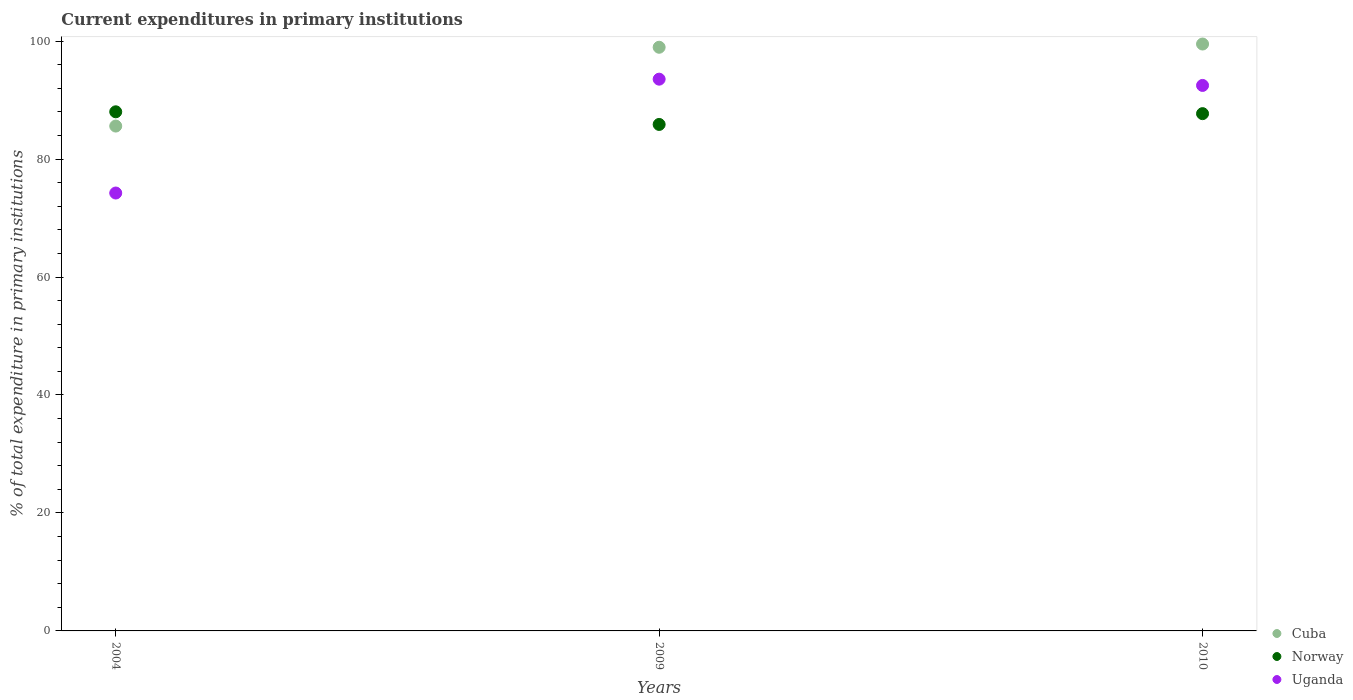Is the number of dotlines equal to the number of legend labels?
Your answer should be very brief. Yes. What is the current expenditures in primary institutions in Norway in 2010?
Ensure brevity in your answer.  87.7. Across all years, what is the maximum current expenditures in primary institutions in Cuba?
Offer a very short reply. 99.5. Across all years, what is the minimum current expenditures in primary institutions in Cuba?
Provide a short and direct response. 85.59. In which year was the current expenditures in primary institutions in Cuba maximum?
Make the answer very short. 2010. In which year was the current expenditures in primary institutions in Norway minimum?
Ensure brevity in your answer.  2009. What is the total current expenditures in primary institutions in Cuba in the graph?
Your answer should be very brief. 284.05. What is the difference between the current expenditures in primary institutions in Norway in 2009 and that in 2010?
Keep it short and to the point. -1.83. What is the difference between the current expenditures in primary institutions in Cuba in 2004 and the current expenditures in primary institutions in Uganda in 2009?
Ensure brevity in your answer.  -7.95. What is the average current expenditures in primary institutions in Cuba per year?
Keep it short and to the point. 94.68. In the year 2009, what is the difference between the current expenditures in primary institutions in Norway and current expenditures in primary institutions in Cuba?
Provide a succinct answer. -13.09. In how many years, is the current expenditures in primary institutions in Norway greater than 48 %?
Give a very brief answer. 3. What is the ratio of the current expenditures in primary institutions in Cuba in 2009 to that in 2010?
Your response must be concise. 0.99. Is the current expenditures in primary institutions in Norway in 2009 less than that in 2010?
Give a very brief answer. Yes. Is the difference between the current expenditures in primary institutions in Norway in 2004 and 2010 greater than the difference between the current expenditures in primary institutions in Cuba in 2004 and 2010?
Your answer should be compact. Yes. What is the difference between the highest and the second highest current expenditures in primary institutions in Norway?
Your answer should be compact. 0.31. What is the difference between the highest and the lowest current expenditures in primary institutions in Uganda?
Offer a terse response. 19.3. In how many years, is the current expenditures in primary institutions in Norway greater than the average current expenditures in primary institutions in Norway taken over all years?
Make the answer very short. 2. Is the sum of the current expenditures in primary institutions in Cuba in 2004 and 2010 greater than the maximum current expenditures in primary institutions in Uganda across all years?
Provide a succinct answer. Yes. Is it the case that in every year, the sum of the current expenditures in primary institutions in Uganda and current expenditures in primary institutions in Norway  is greater than the current expenditures in primary institutions in Cuba?
Offer a terse response. Yes. Is the current expenditures in primary institutions in Cuba strictly less than the current expenditures in primary institutions in Norway over the years?
Your answer should be very brief. No. How many dotlines are there?
Provide a short and direct response. 3. Are the values on the major ticks of Y-axis written in scientific E-notation?
Ensure brevity in your answer.  No. Does the graph contain any zero values?
Make the answer very short. No. Where does the legend appear in the graph?
Offer a very short reply. Bottom right. How many legend labels are there?
Provide a short and direct response. 3. How are the legend labels stacked?
Give a very brief answer. Vertical. What is the title of the graph?
Give a very brief answer. Current expenditures in primary institutions. Does "Iraq" appear as one of the legend labels in the graph?
Keep it short and to the point. No. What is the label or title of the X-axis?
Give a very brief answer. Years. What is the label or title of the Y-axis?
Offer a terse response. % of total expenditure in primary institutions. What is the % of total expenditure in primary institutions in Cuba in 2004?
Offer a very short reply. 85.59. What is the % of total expenditure in primary institutions of Norway in 2004?
Make the answer very short. 88.01. What is the % of total expenditure in primary institutions of Uganda in 2004?
Your response must be concise. 74.24. What is the % of total expenditure in primary institutions in Cuba in 2009?
Offer a terse response. 98.96. What is the % of total expenditure in primary institutions in Norway in 2009?
Your answer should be compact. 85.87. What is the % of total expenditure in primary institutions in Uganda in 2009?
Provide a short and direct response. 93.55. What is the % of total expenditure in primary institutions in Cuba in 2010?
Keep it short and to the point. 99.5. What is the % of total expenditure in primary institutions of Norway in 2010?
Give a very brief answer. 87.7. What is the % of total expenditure in primary institutions in Uganda in 2010?
Provide a short and direct response. 92.48. Across all years, what is the maximum % of total expenditure in primary institutions in Cuba?
Your answer should be compact. 99.5. Across all years, what is the maximum % of total expenditure in primary institutions in Norway?
Keep it short and to the point. 88.01. Across all years, what is the maximum % of total expenditure in primary institutions of Uganda?
Your answer should be very brief. 93.55. Across all years, what is the minimum % of total expenditure in primary institutions of Cuba?
Offer a terse response. 85.59. Across all years, what is the minimum % of total expenditure in primary institutions of Norway?
Ensure brevity in your answer.  85.87. Across all years, what is the minimum % of total expenditure in primary institutions of Uganda?
Your answer should be compact. 74.24. What is the total % of total expenditure in primary institutions of Cuba in the graph?
Make the answer very short. 284.05. What is the total % of total expenditure in primary institutions of Norway in the graph?
Your answer should be very brief. 261.58. What is the total % of total expenditure in primary institutions in Uganda in the graph?
Offer a terse response. 260.27. What is the difference between the % of total expenditure in primary institutions of Cuba in 2004 and that in 2009?
Give a very brief answer. -13.36. What is the difference between the % of total expenditure in primary institutions in Norway in 2004 and that in 2009?
Offer a very short reply. 2.14. What is the difference between the % of total expenditure in primary institutions of Uganda in 2004 and that in 2009?
Give a very brief answer. -19.3. What is the difference between the % of total expenditure in primary institutions in Cuba in 2004 and that in 2010?
Ensure brevity in your answer.  -13.91. What is the difference between the % of total expenditure in primary institutions of Norway in 2004 and that in 2010?
Provide a short and direct response. 0.31. What is the difference between the % of total expenditure in primary institutions in Uganda in 2004 and that in 2010?
Offer a terse response. -18.24. What is the difference between the % of total expenditure in primary institutions in Cuba in 2009 and that in 2010?
Provide a succinct answer. -0.55. What is the difference between the % of total expenditure in primary institutions in Norway in 2009 and that in 2010?
Offer a very short reply. -1.83. What is the difference between the % of total expenditure in primary institutions of Uganda in 2009 and that in 2010?
Provide a succinct answer. 1.06. What is the difference between the % of total expenditure in primary institutions in Cuba in 2004 and the % of total expenditure in primary institutions in Norway in 2009?
Provide a short and direct response. -0.28. What is the difference between the % of total expenditure in primary institutions in Cuba in 2004 and the % of total expenditure in primary institutions in Uganda in 2009?
Offer a terse response. -7.95. What is the difference between the % of total expenditure in primary institutions of Norway in 2004 and the % of total expenditure in primary institutions of Uganda in 2009?
Your answer should be very brief. -5.53. What is the difference between the % of total expenditure in primary institutions in Cuba in 2004 and the % of total expenditure in primary institutions in Norway in 2010?
Make the answer very short. -2.11. What is the difference between the % of total expenditure in primary institutions of Cuba in 2004 and the % of total expenditure in primary institutions of Uganda in 2010?
Your answer should be compact. -6.89. What is the difference between the % of total expenditure in primary institutions in Norway in 2004 and the % of total expenditure in primary institutions in Uganda in 2010?
Offer a terse response. -4.47. What is the difference between the % of total expenditure in primary institutions of Cuba in 2009 and the % of total expenditure in primary institutions of Norway in 2010?
Keep it short and to the point. 11.26. What is the difference between the % of total expenditure in primary institutions of Cuba in 2009 and the % of total expenditure in primary institutions of Uganda in 2010?
Ensure brevity in your answer.  6.47. What is the difference between the % of total expenditure in primary institutions of Norway in 2009 and the % of total expenditure in primary institutions of Uganda in 2010?
Make the answer very short. -6.61. What is the average % of total expenditure in primary institutions in Cuba per year?
Offer a very short reply. 94.68. What is the average % of total expenditure in primary institutions in Norway per year?
Your answer should be very brief. 87.19. What is the average % of total expenditure in primary institutions in Uganda per year?
Ensure brevity in your answer.  86.76. In the year 2004, what is the difference between the % of total expenditure in primary institutions of Cuba and % of total expenditure in primary institutions of Norway?
Give a very brief answer. -2.42. In the year 2004, what is the difference between the % of total expenditure in primary institutions in Cuba and % of total expenditure in primary institutions in Uganda?
Keep it short and to the point. 11.35. In the year 2004, what is the difference between the % of total expenditure in primary institutions of Norway and % of total expenditure in primary institutions of Uganda?
Your answer should be compact. 13.77. In the year 2009, what is the difference between the % of total expenditure in primary institutions in Cuba and % of total expenditure in primary institutions in Norway?
Provide a succinct answer. 13.09. In the year 2009, what is the difference between the % of total expenditure in primary institutions in Cuba and % of total expenditure in primary institutions in Uganda?
Your answer should be compact. 5.41. In the year 2009, what is the difference between the % of total expenditure in primary institutions in Norway and % of total expenditure in primary institutions in Uganda?
Make the answer very short. -7.68. In the year 2010, what is the difference between the % of total expenditure in primary institutions of Cuba and % of total expenditure in primary institutions of Norway?
Your answer should be very brief. 11.8. In the year 2010, what is the difference between the % of total expenditure in primary institutions of Cuba and % of total expenditure in primary institutions of Uganda?
Your answer should be very brief. 7.02. In the year 2010, what is the difference between the % of total expenditure in primary institutions in Norway and % of total expenditure in primary institutions in Uganda?
Your answer should be very brief. -4.78. What is the ratio of the % of total expenditure in primary institutions in Cuba in 2004 to that in 2009?
Keep it short and to the point. 0.86. What is the ratio of the % of total expenditure in primary institutions of Uganda in 2004 to that in 2009?
Offer a terse response. 0.79. What is the ratio of the % of total expenditure in primary institutions in Cuba in 2004 to that in 2010?
Keep it short and to the point. 0.86. What is the ratio of the % of total expenditure in primary institutions of Uganda in 2004 to that in 2010?
Provide a short and direct response. 0.8. What is the ratio of the % of total expenditure in primary institutions in Cuba in 2009 to that in 2010?
Your answer should be very brief. 0.99. What is the ratio of the % of total expenditure in primary institutions in Norway in 2009 to that in 2010?
Offer a terse response. 0.98. What is the ratio of the % of total expenditure in primary institutions in Uganda in 2009 to that in 2010?
Offer a very short reply. 1.01. What is the difference between the highest and the second highest % of total expenditure in primary institutions in Cuba?
Provide a short and direct response. 0.55. What is the difference between the highest and the second highest % of total expenditure in primary institutions of Norway?
Keep it short and to the point. 0.31. What is the difference between the highest and the second highest % of total expenditure in primary institutions in Uganda?
Your response must be concise. 1.06. What is the difference between the highest and the lowest % of total expenditure in primary institutions of Cuba?
Provide a short and direct response. 13.91. What is the difference between the highest and the lowest % of total expenditure in primary institutions of Norway?
Keep it short and to the point. 2.14. What is the difference between the highest and the lowest % of total expenditure in primary institutions of Uganda?
Offer a very short reply. 19.3. 